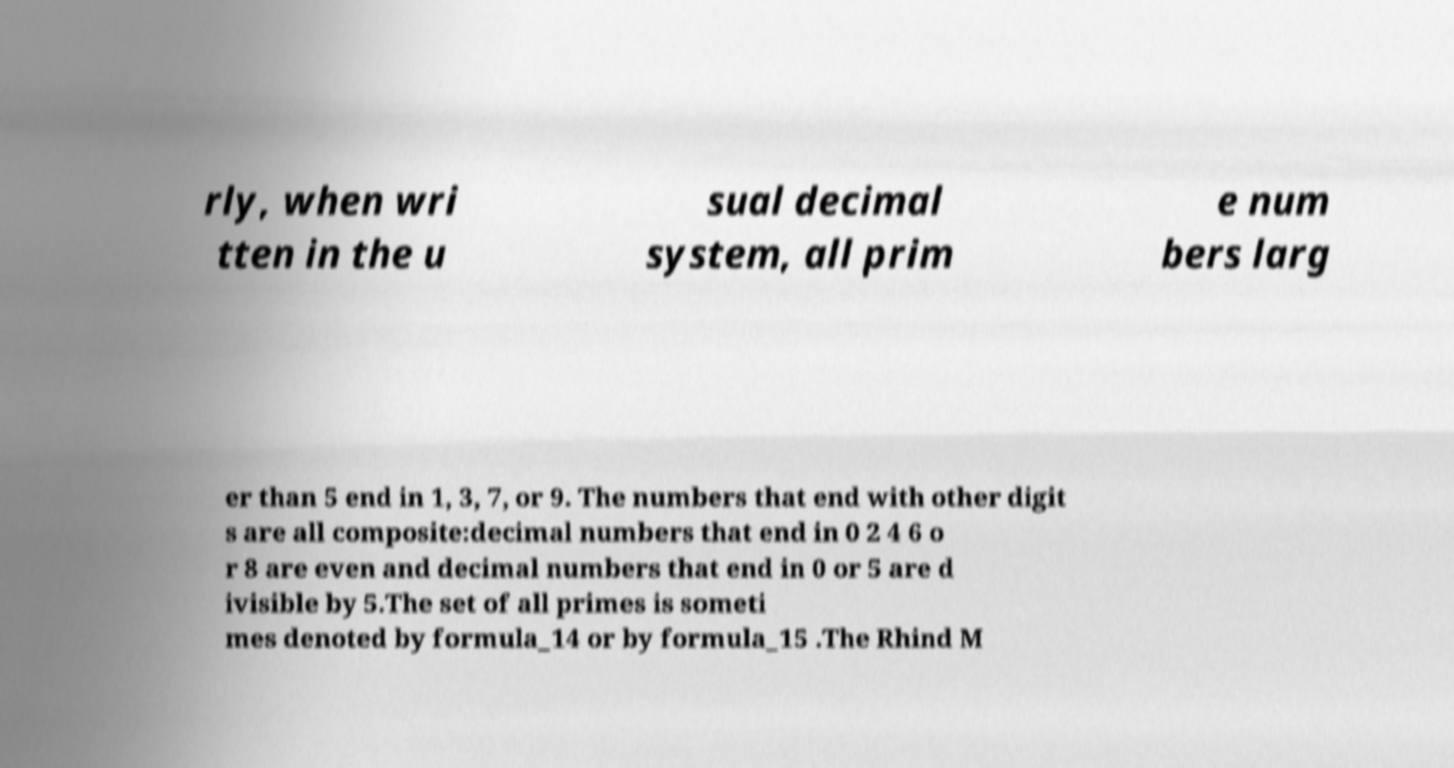There's text embedded in this image that I need extracted. Can you transcribe it verbatim? rly, when wri tten in the u sual decimal system, all prim e num bers larg er than 5 end in 1, 3, 7, or 9. The numbers that end with other digit s are all composite:decimal numbers that end in 0 2 4 6 o r 8 are even and decimal numbers that end in 0 or 5 are d ivisible by 5.The set of all primes is someti mes denoted by formula_14 or by formula_15 .The Rhind M 